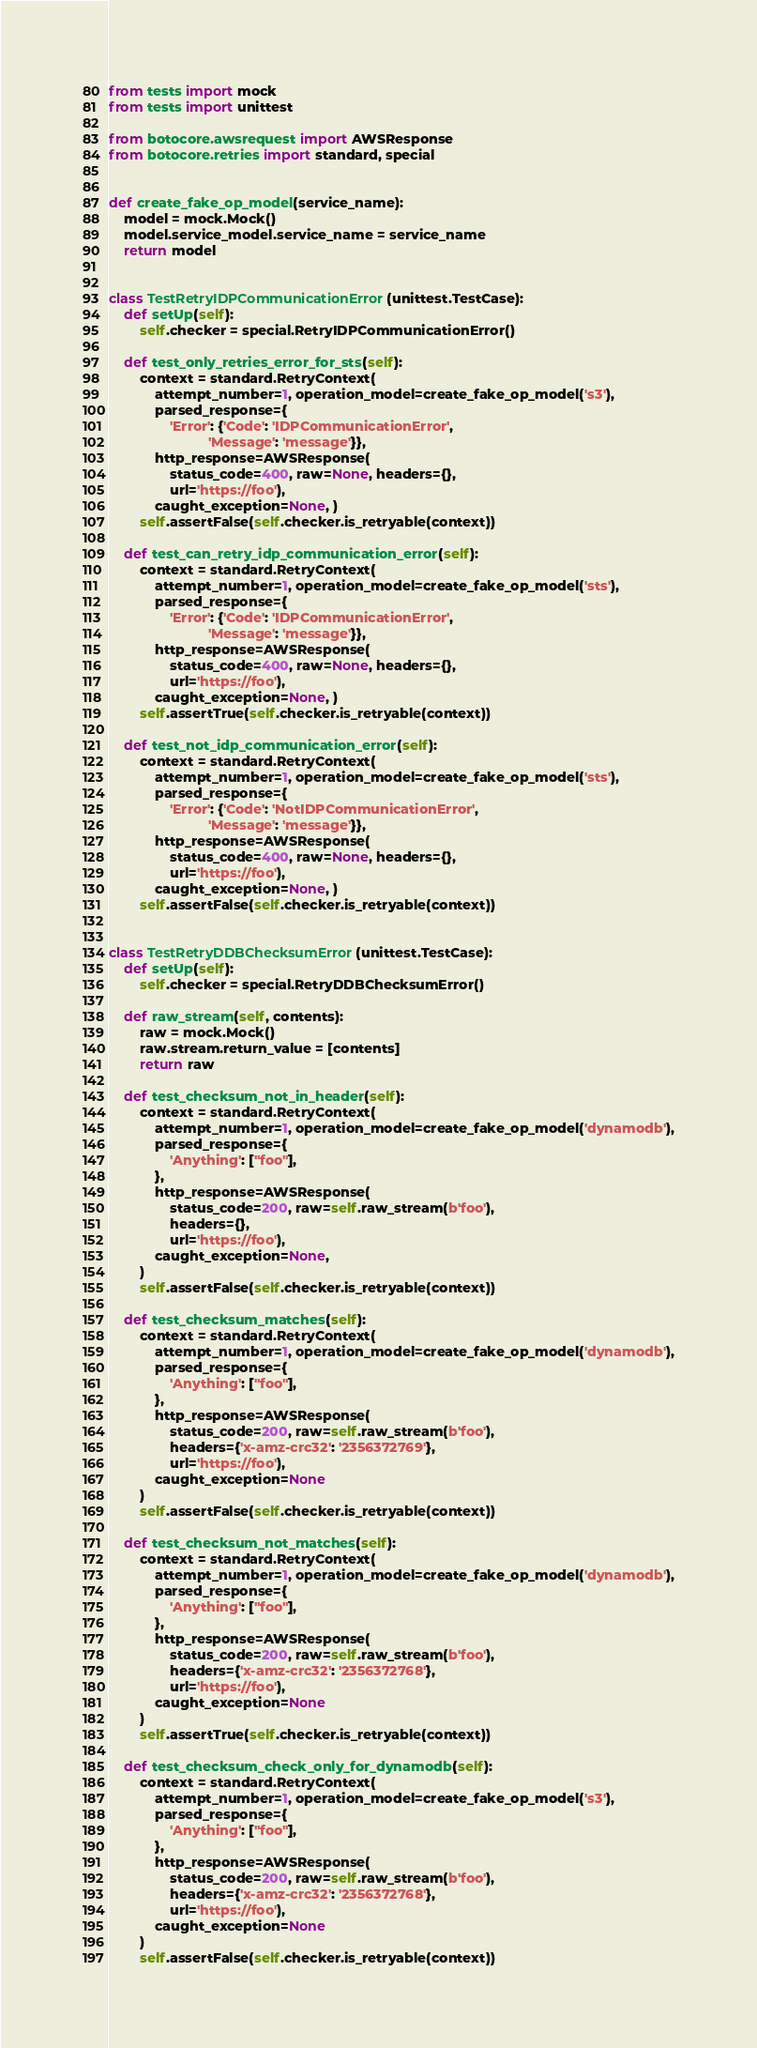Convert code to text. <code><loc_0><loc_0><loc_500><loc_500><_Python_>from tests import mock
from tests import unittest

from botocore.awsrequest import AWSResponse
from botocore.retries import standard, special


def create_fake_op_model(service_name):
    model = mock.Mock()
    model.service_model.service_name = service_name
    return model


class TestRetryIDPCommunicationError(unittest.TestCase):
    def setUp(self):
        self.checker = special.RetryIDPCommunicationError()

    def test_only_retries_error_for_sts(self):
        context = standard.RetryContext(
            attempt_number=1, operation_model=create_fake_op_model('s3'),
            parsed_response={
                'Error': {'Code': 'IDPCommunicationError',
                          'Message': 'message'}},
            http_response=AWSResponse(
                status_code=400, raw=None, headers={},
                url='https://foo'),
            caught_exception=None, )
        self.assertFalse(self.checker.is_retryable(context))

    def test_can_retry_idp_communication_error(self):
        context = standard.RetryContext(
            attempt_number=1, operation_model=create_fake_op_model('sts'),
            parsed_response={
                'Error': {'Code': 'IDPCommunicationError',
                          'Message': 'message'}},
            http_response=AWSResponse(
                status_code=400, raw=None, headers={},
                url='https://foo'),
            caught_exception=None, )
        self.assertTrue(self.checker.is_retryable(context))

    def test_not_idp_communication_error(self):
        context = standard.RetryContext(
            attempt_number=1, operation_model=create_fake_op_model('sts'),
            parsed_response={
                'Error': {'Code': 'NotIDPCommunicationError',
                          'Message': 'message'}},
            http_response=AWSResponse(
                status_code=400, raw=None, headers={},
                url='https://foo'),
            caught_exception=None, )
        self.assertFalse(self.checker.is_retryable(context))


class TestRetryDDBChecksumError(unittest.TestCase):
    def setUp(self):
        self.checker = special.RetryDDBChecksumError()

    def raw_stream(self, contents):
        raw = mock.Mock()
        raw.stream.return_value = [contents]
        return raw

    def test_checksum_not_in_header(self):
        context = standard.RetryContext(
            attempt_number=1, operation_model=create_fake_op_model('dynamodb'),
            parsed_response={
                'Anything': ["foo"],
            },
            http_response=AWSResponse(
                status_code=200, raw=self.raw_stream(b'foo'),
                headers={},
                url='https://foo'),
            caught_exception=None,
        )
        self.assertFalse(self.checker.is_retryable(context))

    def test_checksum_matches(self):
        context = standard.RetryContext(
            attempt_number=1, operation_model=create_fake_op_model('dynamodb'),
            parsed_response={
                'Anything': ["foo"],
            },
            http_response=AWSResponse(
                status_code=200, raw=self.raw_stream(b'foo'),
                headers={'x-amz-crc32': '2356372769'},
                url='https://foo'),
            caught_exception=None
        )
        self.assertFalse(self.checker.is_retryable(context))

    def test_checksum_not_matches(self):
        context = standard.RetryContext(
            attempt_number=1, operation_model=create_fake_op_model('dynamodb'),
            parsed_response={
                'Anything': ["foo"],
            },
            http_response=AWSResponse(
                status_code=200, raw=self.raw_stream(b'foo'),
                headers={'x-amz-crc32': '2356372768'},
                url='https://foo'),
            caught_exception=None
        )
        self.assertTrue(self.checker.is_retryable(context))

    def test_checksum_check_only_for_dynamodb(self):
        context = standard.RetryContext(
            attempt_number=1, operation_model=create_fake_op_model('s3'),
            parsed_response={
                'Anything': ["foo"],
            },
            http_response=AWSResponse(
                status_code=200, raw=self.raw_stream(b'foo'),
                headers={'x-amz-crc32': '2356372768'},
                url='https://foo'),
            caught_exception=None
        )
        self.assertFalse(self.checker.is_retryable(context))
</code> 